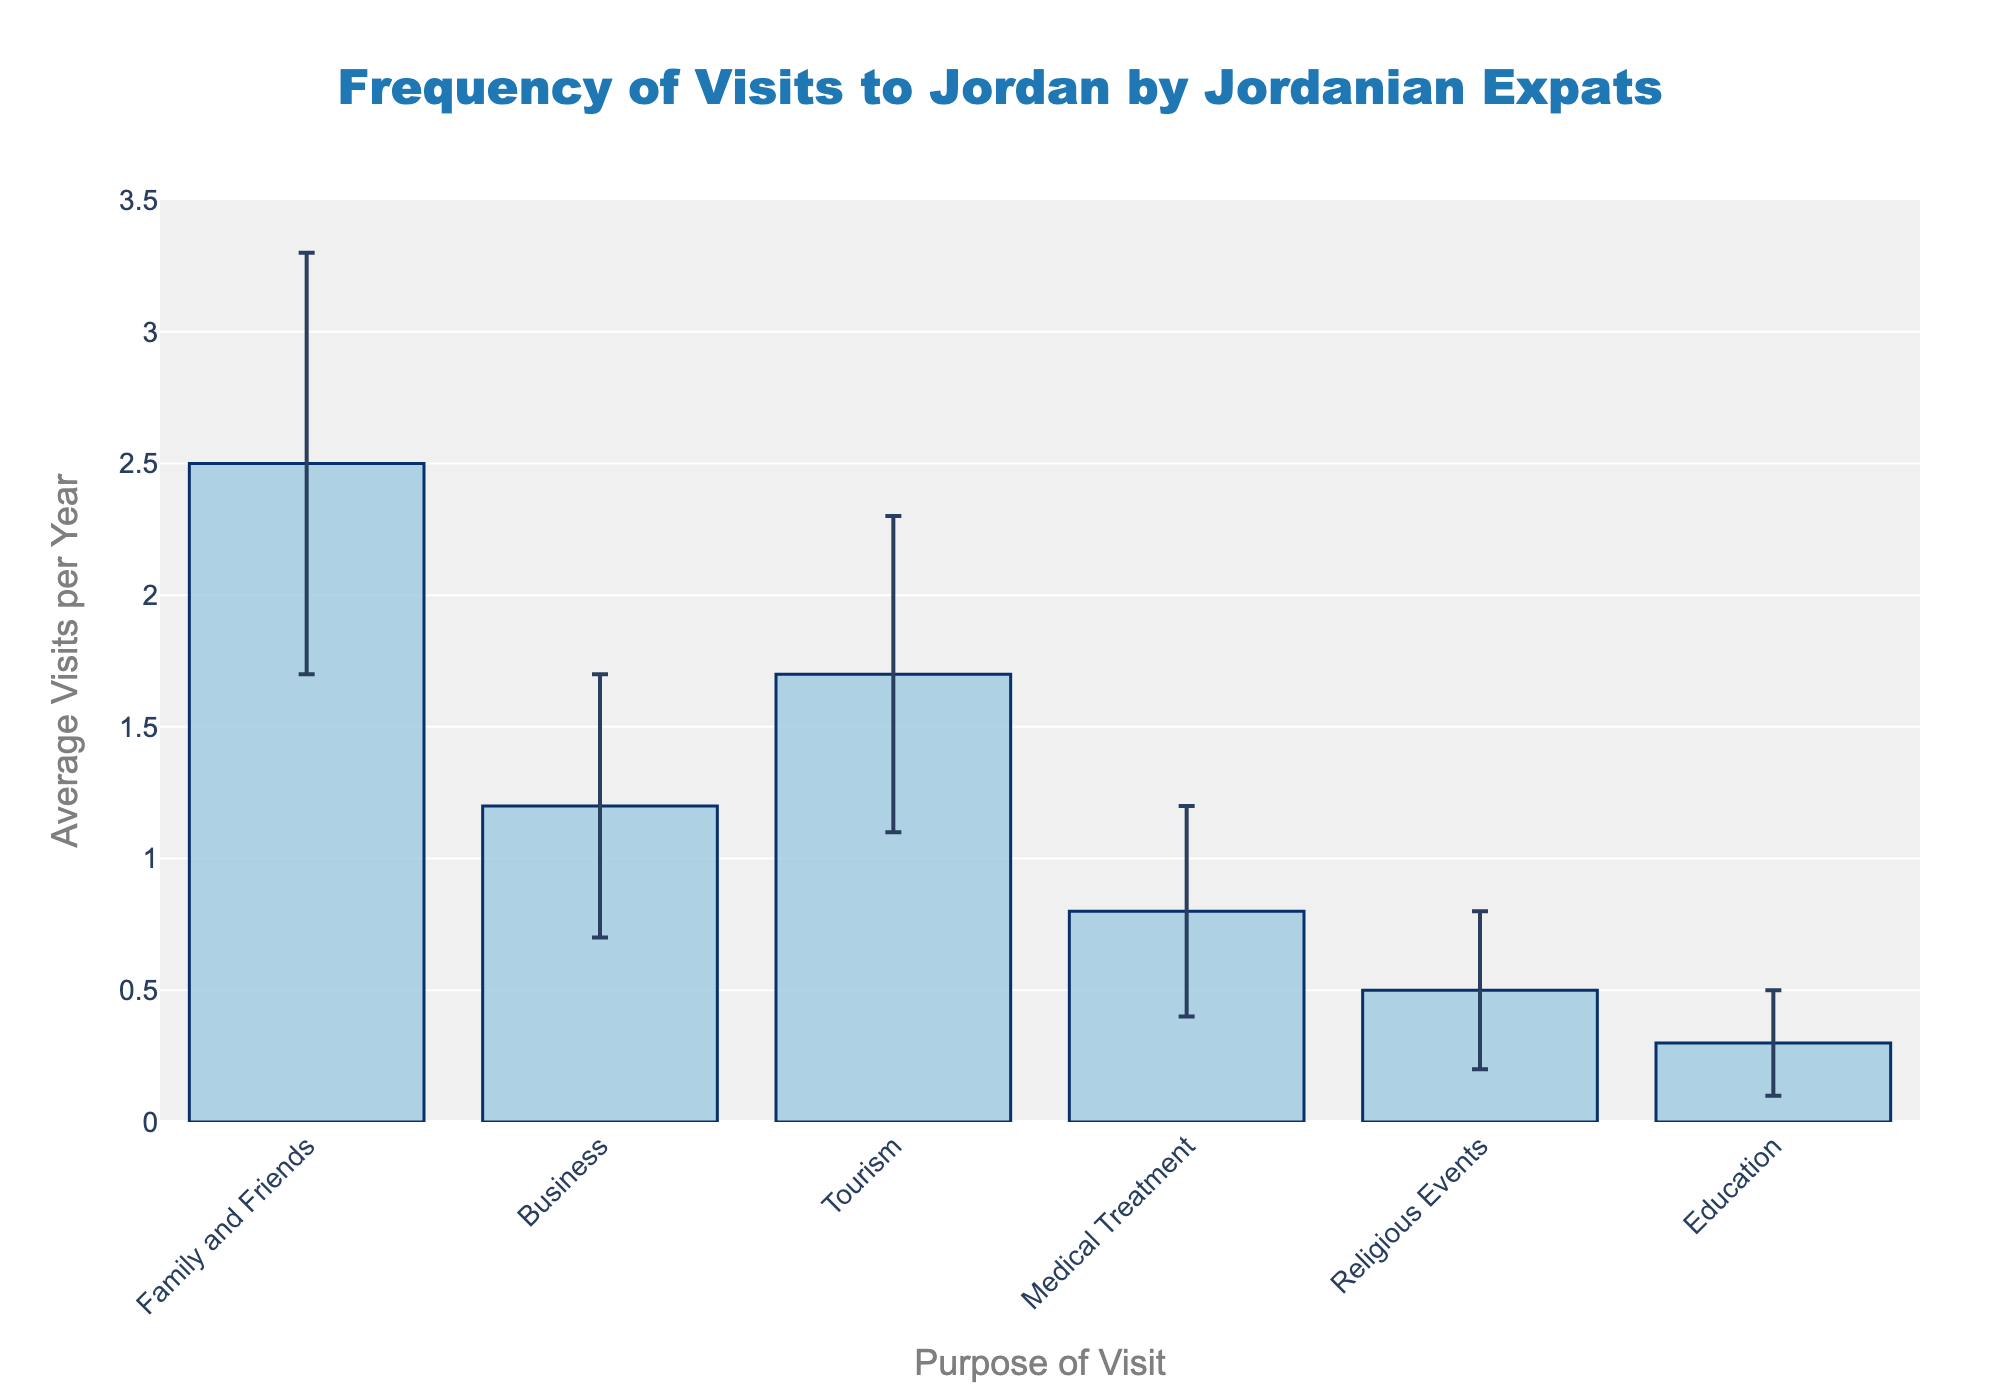What is the title of the figure? The title of the figure is usually displayed prominently at the top. In this figure, the title is centered and reads "Frequency of Visits to Jordan by Jordanian Expats," indicating the subject of the data.
Answer: Frequency of Visits to Jordan by Jordanian Expats Which purpose of visit has the highest average visits per year? To find the purpose with the highest average visits, look at the bar heights in the chart. The highest bar corresponds to "Family and Friends" with an average of 2.5 visits per year.
Answer: Family and Friends How many categories of purposes are shown in the figure? Counting the number of distinct bars in the figure helps determine the number of categories. There are six bars, each representing a different purpose.
Answer: Six Which purpose of visit has the largest standard deviation? The error bars represent the standard deviation. By comparing the lengths of these error bars, the longest one corresponds to "Family and Friends" with a standard deviation of 0.8.
Answer: Family and Friends What is the average number of visits per year for business purposes? The bar labeled "Business" shows its height or y-value, which represents the average number of visits per year. This value is 1.2.
Answer: 1.2 Compare the average visits per year for "Tourism" and "Business." Which is higher and by how much? The bar heights for "Tourism" and "Business" show averages of 1.7 and 1.2, respectively. "Tourism" is higher; the difference is calculated as 1.7 - 1.2 = 0.5.
Answer: Tourism is higher by 0.5 What is the combined average number of visits per year for "Medical Treatment" and "Religious Events"? Add the average visits per year for "Medical Treatment" (0.8) and "Religious Events" (0.5). The sum is 0.8 + 0.5 = 1.3.
Answer: 1.3 Which purpose of visit has the smallest range considering the average visits per year ± standard deviation? To find this, calculate the range for each purpose, considering average ± standard deviation. The smallest range corresponds to "Education," with an average of 0.3 and a standard deviation of 0.2 (range is 0.3 ± 0.2 = [0.1, 0.5]).
Answer: Education What is the total standard deviation sum for all purposes of visit? Sum the standard deviations for all categories: 0.8 + 0.5 + 0.6 + 0.4 + 0.3 + 0.2 = 2.8.
Answer: 2.8 What does the error bar signify in this figure? Error bars represent the variability or standard deviation of the average visits per year for each purpose of visit. Long error bars indicate high variability, while short ones indicate low variability.
Answer: Standard deviation/variability 